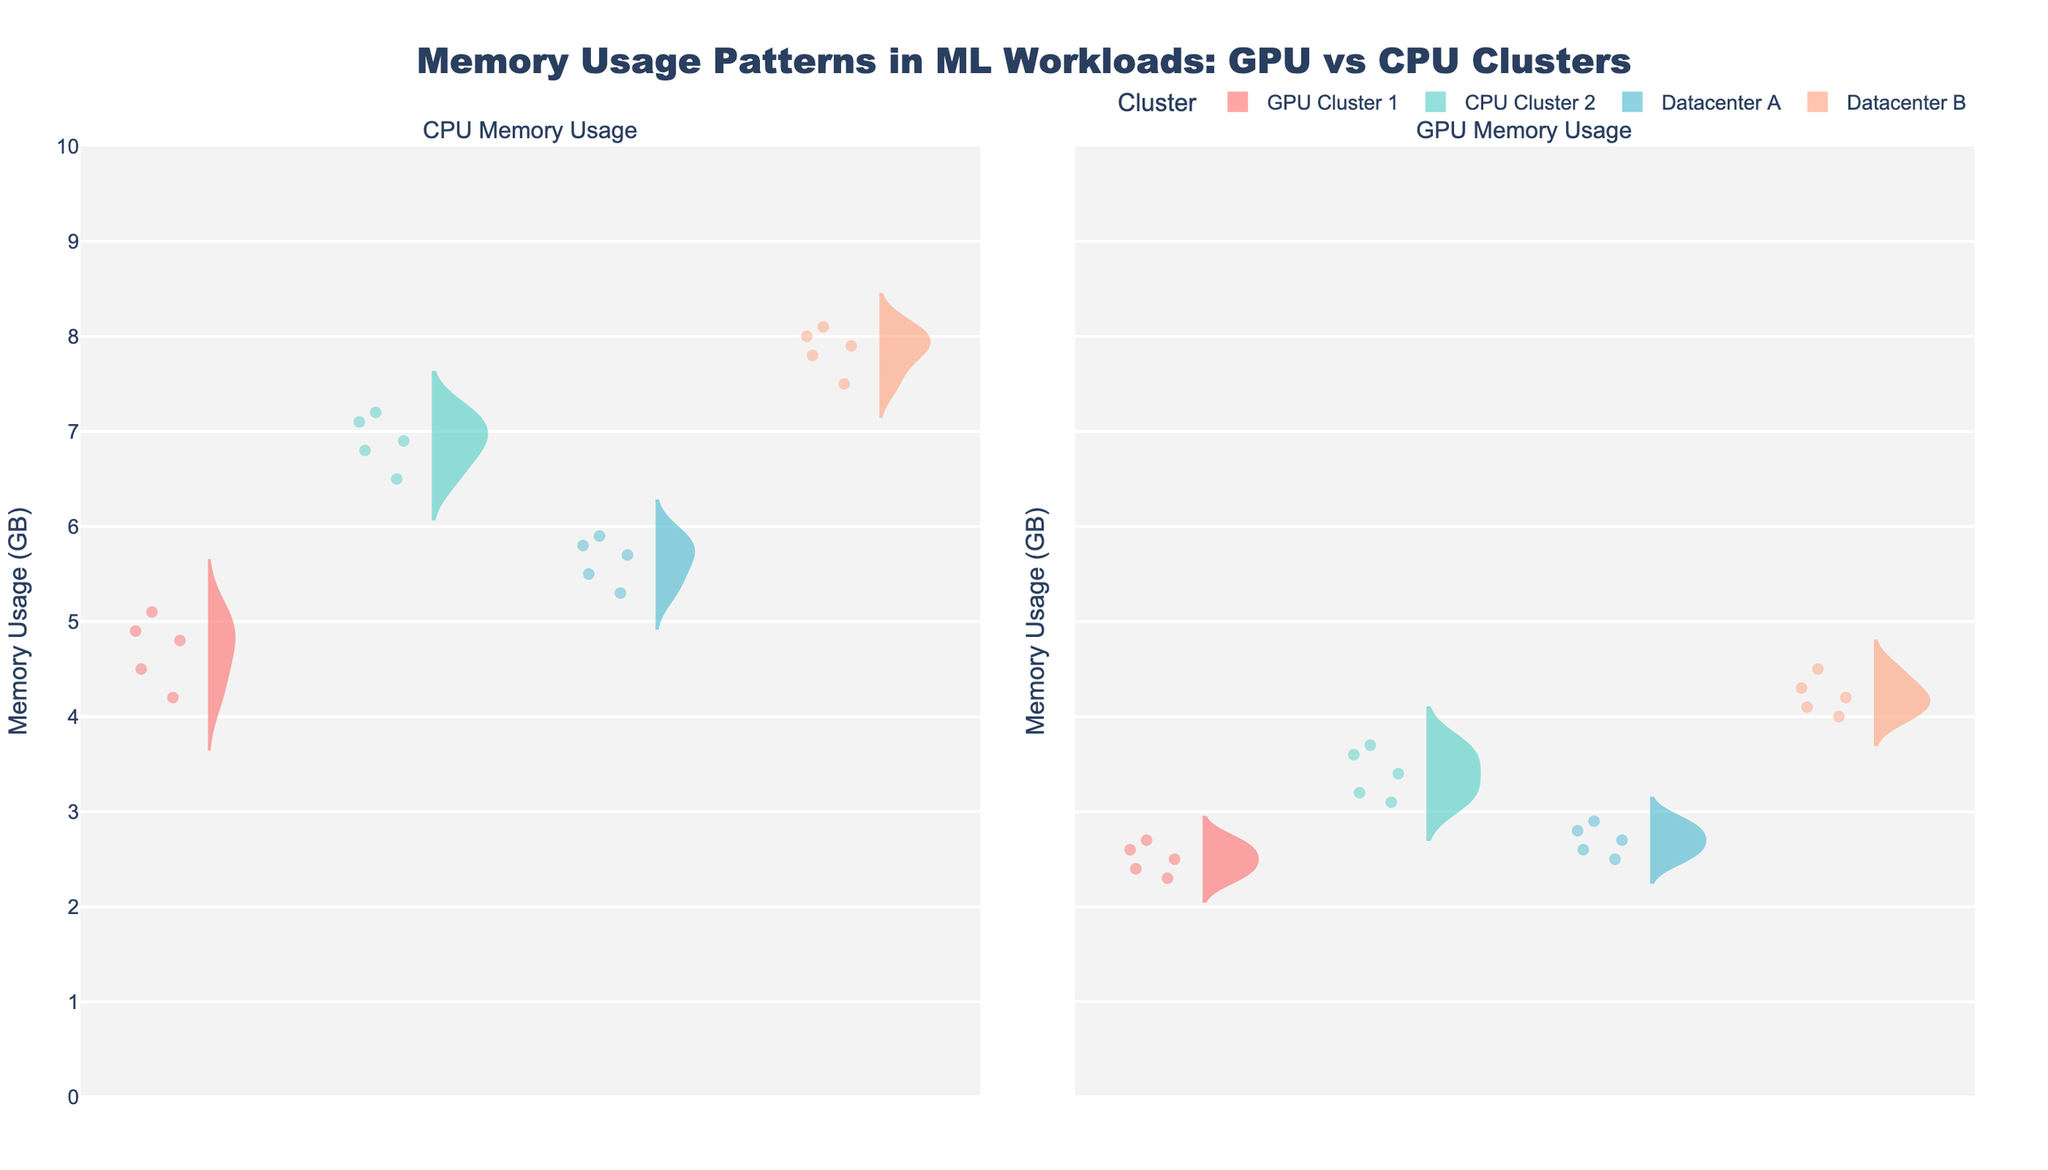What are the titles of the two subplots? The titles of the two subplots can be found at the top of each chart in the figure. The left subplot is titled "CPU Memory Usage" and the right subplot is titled "GPU Memory Usage."
Answer: "CPU Memory Usage" and "GPU Memory Usage." What is the highest memory usage observed in the Datacenter B GPU group? To find the highest memory usage in the Datacenter B GPU group, look for the maximum value within the range of the Datacenter B group in the GPU subplot. It appears to be around 4.5 GB.
Answer: 4.5 GB Which cluster shows the lowest average memory usage for the GPU group? To determine the average memory usage for each GPU group, visually inspect the distribution in the right subplot. The GPU Cluster 1 group has the smallest spread and centers around 2.5 GB.
Answer: GPU Cluster 1 Are memory usage patterns generally higher on CPUs or GPUs across clusters? By comparing the overall distribution in the left and right subplots, it becomes evident that CPU memory usage patterns have a higher range and central tendency compared to those of GPUs.
Answer: CPUs Which cluster has the most tightly packed memory usage for the CPU group? Analyze each cluster in the left subplot to determine which one has the least spread. The Datacenter A cluster appears to have the most tightly packed (narrow) distribution for CPU memory usage.
Answer: Datacenter A What is the range of memory usage for the Datacenter A GPU group? The range is the difference between the maximum and minimum values. For the Datacenter A GPU group, the minimum is around 2.5 GB and the maximum is around 2.9 GB. The range is thus 2.9 - 2.5 = 0.4 GB.
Answer: 0.4 GB Is there any cluster where the GPU memory usage exceeds the CPU memory usage? Scan both subplots to see if there's any overlap where GPU memory usage surpasses CPU memory usage. No such pattern is observed; GPU usage is consistently lower than CPU usage within each cluster.
Answer: No Which cluster has the widest spread in CPU memory usage? Observe each cluster in the left subplot. CPU Cluster 2 displays the widest spread, with values ranging roughly between 6.5 and 7.2 GB.
Answer: CPU Cluster 2 What is the median value of memory usage for GPU in the CPU Cluster 2? The median is the middle value of a sorted list. For CPU Cluster 2 GPU, the values are: 3.1, 3.2, 3.4, 3.6, 3.7. Thus, the median value, or middle value when sorted, is 3.4 GB.
Answer: 3.4 GB 